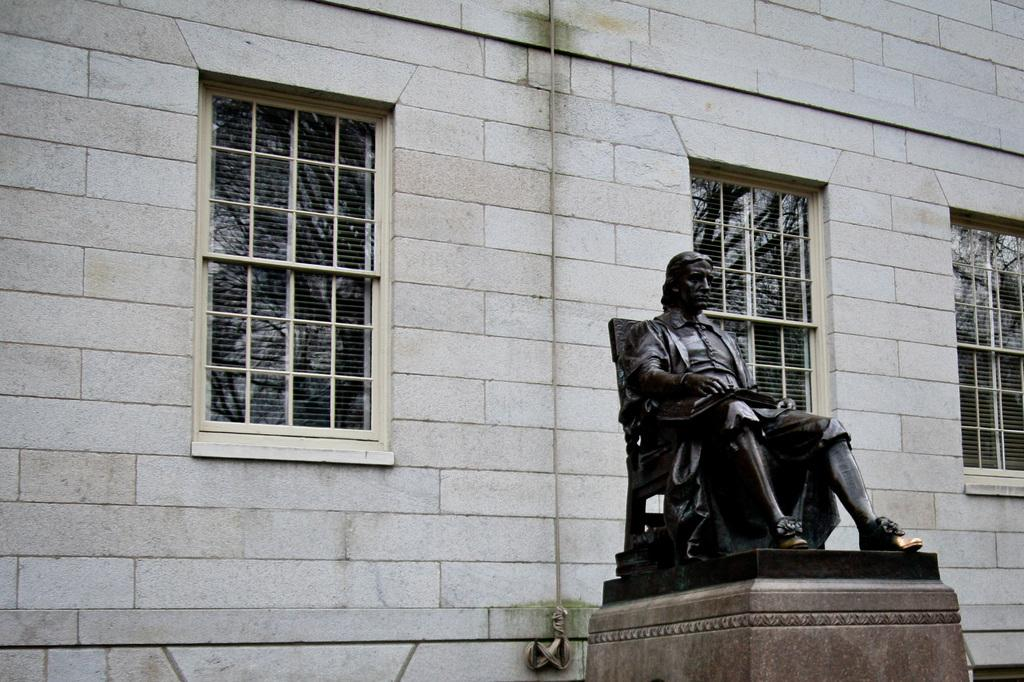What is the main subject of the image? There is a statue of a person in the image. What is the statue doing in the image? The statue is sitting on a chair. What can be seen through the windows in the image? The details of what can be seen through the windows are not provided, but we know that there are windows in the image. What is visible in the background of the image? There is a wall visible in the background of the image. What type of cast is visible on the statue's arm in the image? There is no cast visible on the statue's arm in the image; it is a statue and not a real person. What type of crib is present in the image? There is no crib present in the image. 